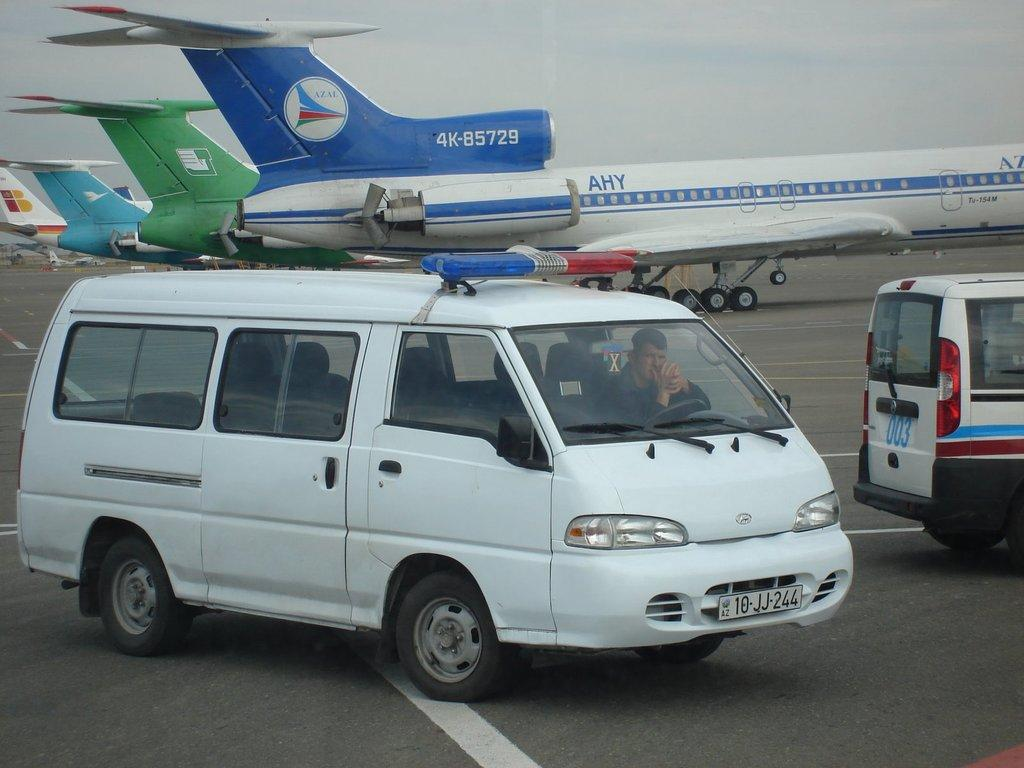What is the main subject of the image? The main subject of the image is airplanes. Are there any other objects or vehicles in the image? Yes, there are two vehicles in the image. What can be seen in the background of the image? The sky is visible in the image. What type of cloth is draped over the zebra in the image? There is no cloth or zebra present in the image. 